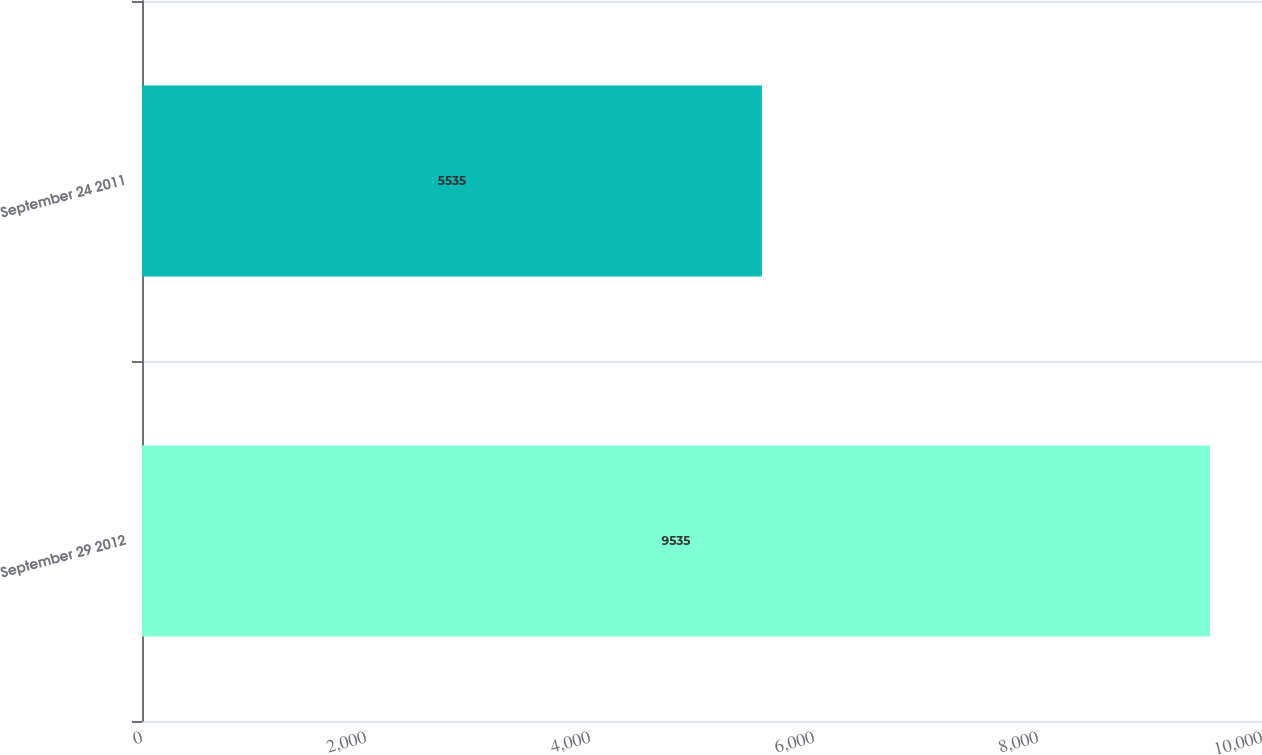Convert chart. <chart><loc_0><loc_0><loc_500><loc_500><bar_chart><fcel>September 29 2012<fcel>September 24 2011<nl><fcel>9535<fcel>5535<nl></chart> 